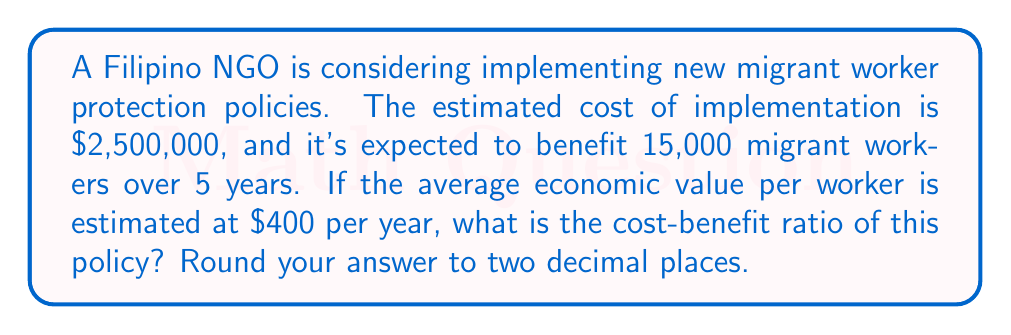Show me your answer to this math problem. To calculate the cost-benefit ratio, we need to follow these steps:

1. Calculate the total benefit:
   - Number of workers: 15,000
   - Benefit per worker per year: $400
   - Number of years: 5
   Total benefit = $15,000 \times $400 \times 5 = $30,000,000

2. Set up the cost-benefit ratio equation:
   $$ \text{Cost-Benefit Ratio} = \frac{\text{Cost}}{\text{Benefit}} $$

3. Plug in the values:
   $$ \text{Cost-Benefit Ratio} = \frac{$2,500,000}{$30,000,000} $$

4. Perform the division:
   $$ \text{Cost-Benefit Ratio} = 0.0833333... $$

5. Round to two decimal places:
   $$ \text{Cost-Benefit Ratio} = 0.08 $$
Answer: 0.08 